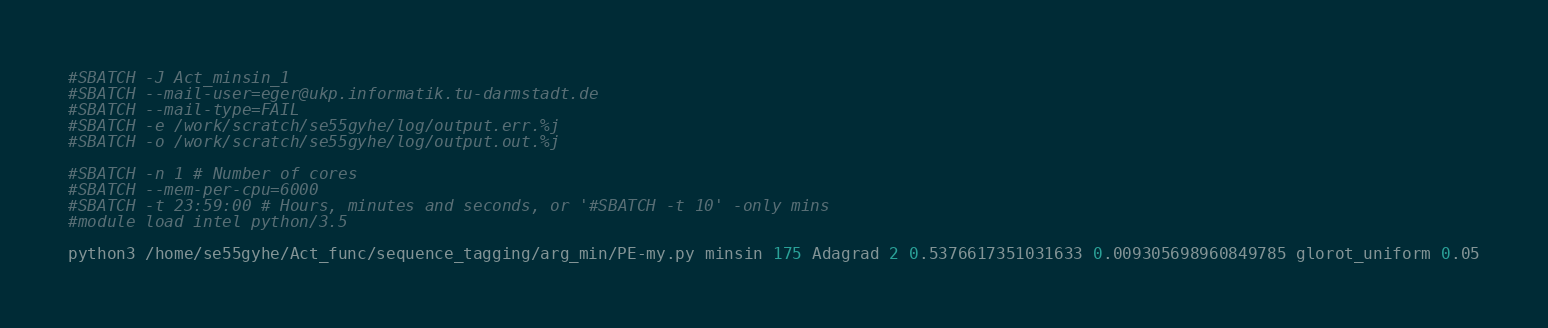Convert code to text. <code><loc_0><loc_0><loc_500><loc_500><_Bash_>#SBATCH -J Act_minsin_1
#SBATCH --mail-user=eger@ukp.informatik.tu-darmstadt.de
#SBATCH --mail-type=FAIL
#SBATCH -e /work/scratch/se55gyhe/log/output.err.%j
#SBATCH -o /work/scratch/se55gyhe/log/output.out.%j

#SBATCH -n 1 # Number of cores
#SBATCH --mem-per-cpu=6000
#SBATCH -t 23:59:00 # Hours, minutes and seconds, or '#SBATCH -t 10' -only mins
#module load intel python/3.5

python3 /home/se55gyhe/Act_func/sequence_tagging/arg_min/PE-my.py minsin 175 Adagrad 2 0.5376617351031633 0.009305698960849785 glorot_uniform 0.05

</code> 